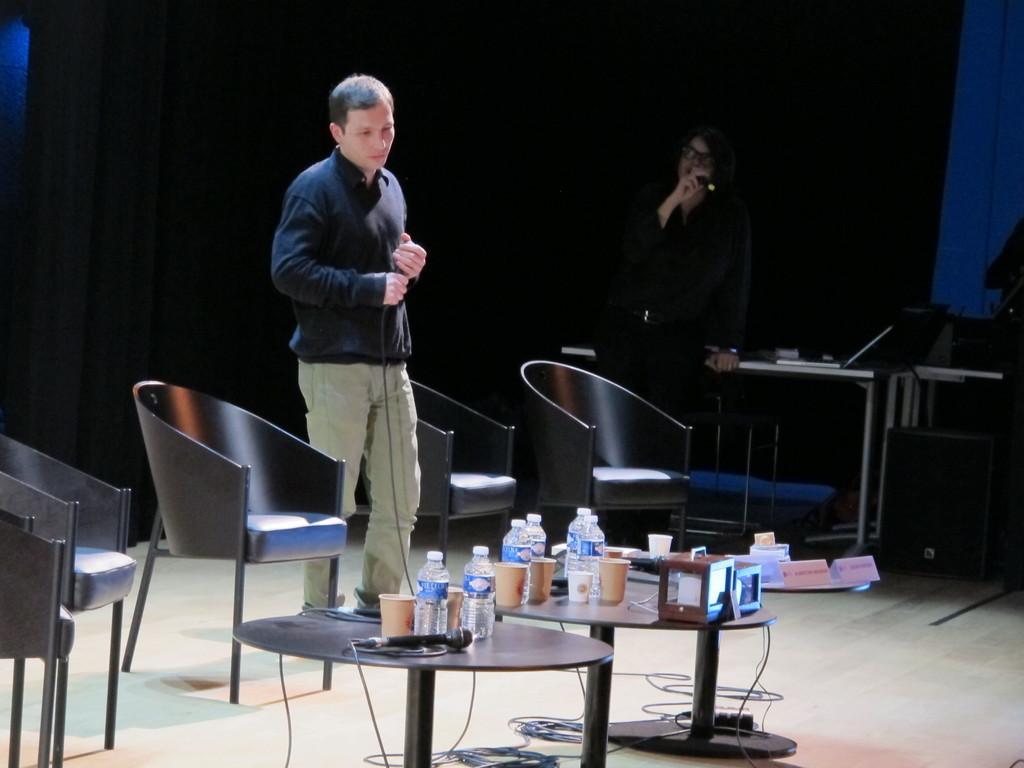Can you describe this image briefly? In this picture there is a man standing near the chairs and the back ground we have, another person holding a microphone and in table we have cups, glasses, water bottles , and a microphone and name boards. 